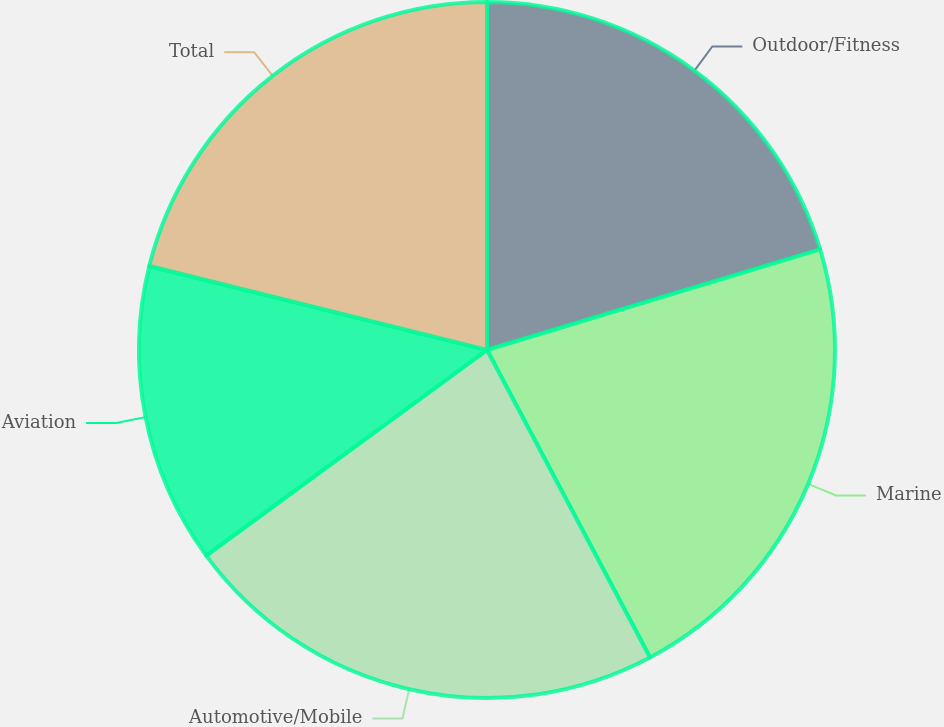Convert chart to OTSL. <chart><loc_0><loc_0><loc_500><loc_500><pie_chart><fcel>Outdoor/Fitness<fcel>Marine<fcel>Automotive/Mobile<fcel>Aviation<fcel>Total<nl><fcel>20.33%<fcel>21.91%<fcel>22.7%<fcel>13.94%<fcel>21.12%<nl></chart> 